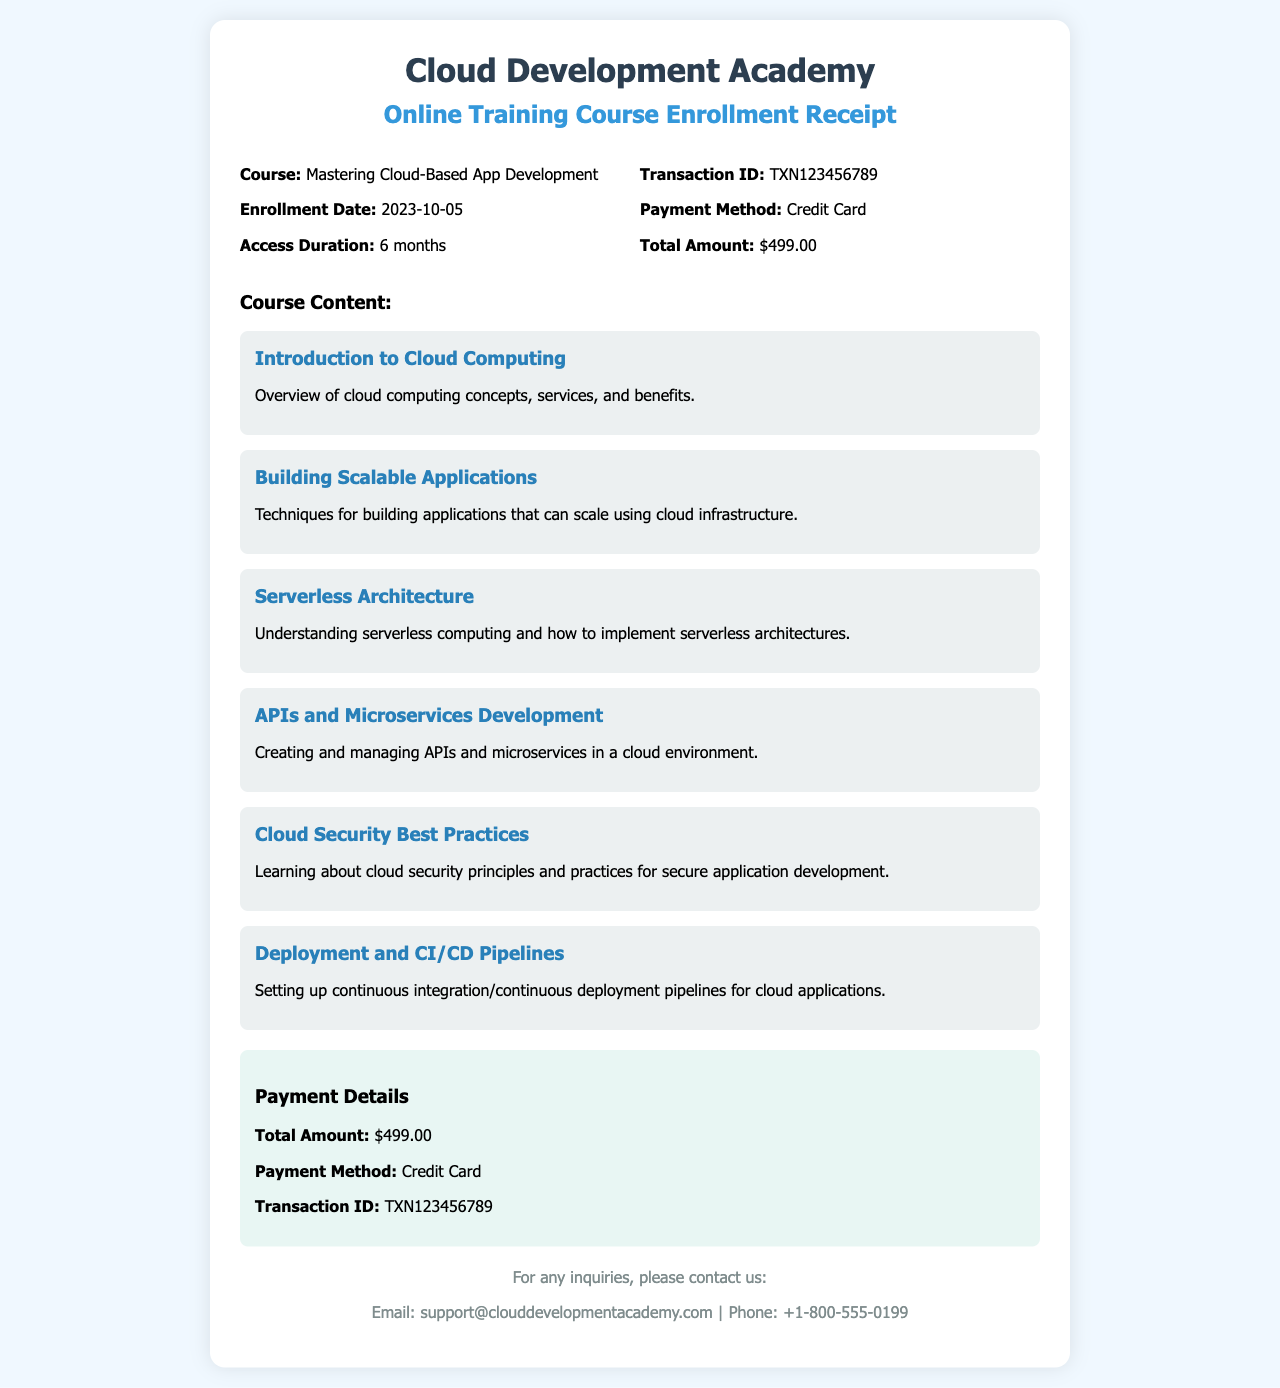What is the course title? The course title is mentioned at the beginning of the receipt, which is "Mastering Cloud-Based App Development."
Answer: Mastering Cloud-Based App Development What is the enrollment date? The enrollment date is specified in the document as "2023-10-05."
Answer: 2023-10-05 How long is the access duration? The access duration is stated in the document as "6 months."
Answer: 6 months What is the total amount paid? The total amount is detailed in the payment section of the document as "$499.00."
Answer: $499.00 What is the transaction ID? The transaction ID is given in the receipt as "TXN123456789."
Answer: TXN123456789 How many modules are listed in the course content? The document lists a total of six modules under the course content.
Answer: 6 What is the payment method used? The payment method is found in the payment details section, which states "Credit Card."
Answer: Credit Card Which module covers cloud security? The module that covers cloud security is titled "Cloud Security Best Practices."
Answer: Cloud Security Best Practices What is provided for inquiries? The document includes contact information for inquiries, specifically an email and a phone number.
Answer: Email and phone number 